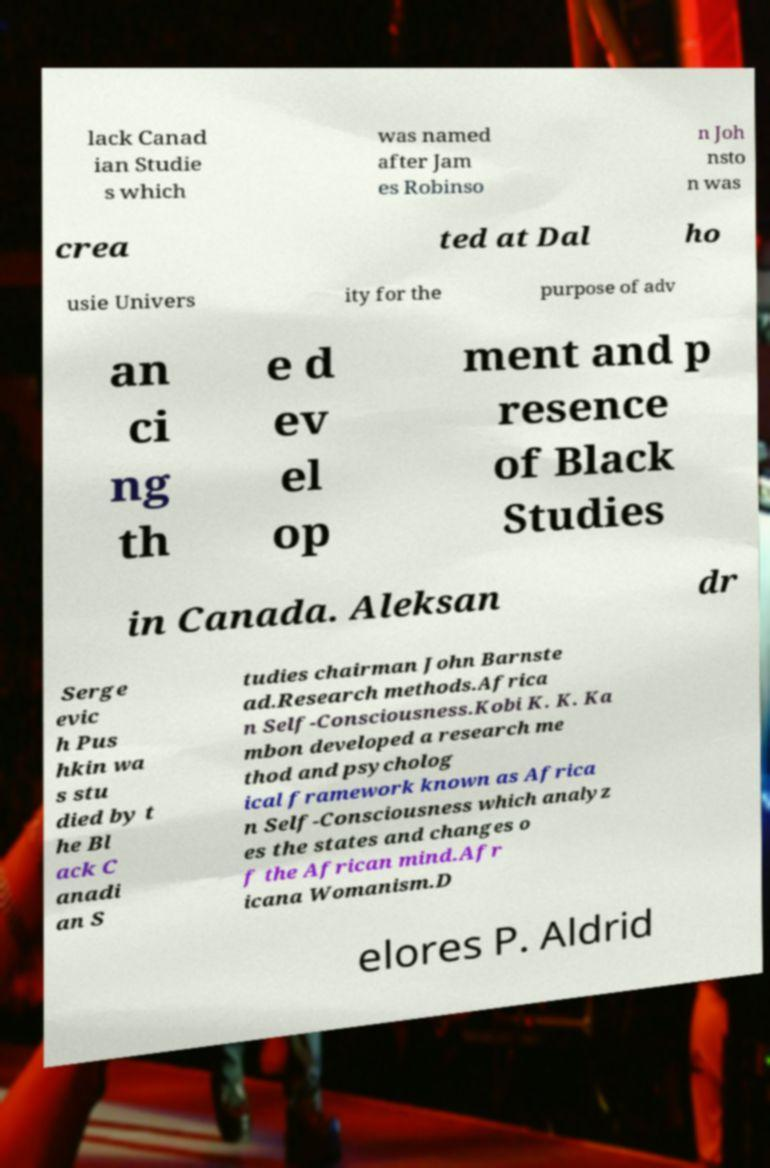I need the written content from this picture converted into text. Can you do that? lack Canad ian Studie s which was named after Jam es Robinso n Joh nsto n was crea ted at Dal ho usie Univers ity for the purpose of adv an ci ng th e d ev el op ment and p resence of Black Studies in Canada. Aleksan dr Serge evic h Pus hkin wa s stu died by t he Bl ack C anadi an S tudies chairman John Barnste ad.Research methods.Africa n Self-Consciousness.Kobi K. K. Ka mbon developed a research me thod and psycholog ical framework known as Africa n Self-Consciousness which analyz es the states and changes o f the African mind.Afr icana Womanism.D elores P. Aldrid 